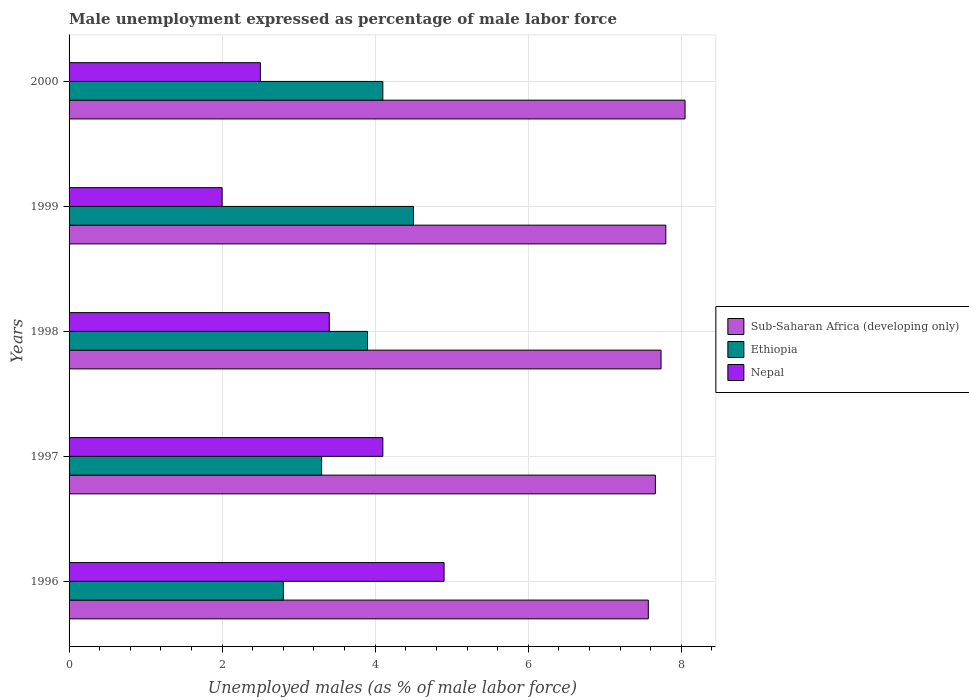Are the number of bars per tick equal to the number of legend labels?
Ensure brevity in your answer.  Yes. Are the number of bars on each tick of the Y-axis equal?
Ensure brevity in your answer.  Yes. How many bars are there on the 2nd tick from the bottom?
Your response must be concise. 3. In how many cases, is the number of bars for a given year not equal to the number of legend labels?
Your response must be concise. 0. What is the unemployment in males in in Nepal in 1997?
Provide a short and direct response. 4.1. Across all years, what is the maximum unemployment in males in in Sub-Saharan Africa (developing only)?
Provide a short and direct response. 8.05. Across all years, what is the minimum unemployment in males in in Ethiopia?
Offer a very short reply. 2.8. In which year was the unemployment in males in in Nepal maximum?
Provide a succinct answer. 1996. In which year was the unemployment in males in in Ethiopia minimum?
Keep it short and to the point. 1996. What is the total unemployment in males in in Sub-Saharan Africa (developing only) in the graph?
Keep it short and to the point. 38.81. What is the difference between the unemployment in males in in Ethiopia in 1996 and that in 2000?
Offer a very short reply. -1.3. What is the difference between the unemployment in males in in Nepal in 1996 and the unemployment in males in in Ethiopia in 2000?
Offer a very short reply. 0.8. What is the average unemployment in males in in Nepal per year?
Provide a short and direct response. 3.38. In the year 2000, what is the difference between the unemployment in males in in Nepal and unemployment in males in in Sub-Saharan Africa (developing only)?
Ensure brevity in your answer.  -5.55. What is the ratio of the unemployment in males in in Ethiopia in 1996 to that in 1999?
Provide a succinct answer. 0.62. What is the difference between the highest and the second highest unemployment in males in in Nepal?
Keep it short and to the point. 0.8. What is the difference between the highest and the lowest unemployment in males in in Sub-Saharan Africa (developing only)?
Your answer should be very brief. 0.48. What does the 2nd bar from the top in 1999 represents?
Your answer should be very brief. Ethiopia. What does the 2nd bar from the bottom in 2000 represents?
Keep it short and to the point. Ethiopia. Is it the case that in every year, the sum of the unemployment in males in in Ethiopia and unemployment in males in in Sub-Saharan Africa (developing only) is greater than the unemployment in males in in Nepal?
Provide a succinct answer. Yes. What is the difference between two consecutive major ticks on the X-axis?
Offer a very short reply. 2. Are the values on the major ticks of X-axis written in scientific E-notation?
Your answer should be compact. No. How many legend labels are there?
Your answer should be compact. 3. How are the legend labels stacked?
Ensure brevity in your answer.  Vertical. What is the title of the graph?
Your answer should be very brief. Male unemployment expressed as percentage of male labor force. What is the label or title of the X-axis?
Offer a very short reply. Unemployed males (as % of male labor force). What is the label or title of the Y-axis?
Your answer should be very brief. Years. What is the Unemployed males (as % of male labor force) in Sub-Saharan Africa (developing only) in 1996?
Your response must be concise. 7.57. What is the Unemployed males (as % of male labor force) of Ethiopia in 1996?
Your answer should be compact. 2.8. What is the Unemployed males (as % of male labor force) of Nepal in 1996?
Provide a short and direct response. 4.9. What is the Unemployed males (as % of male labor force) of Sub-Saharan Africa (developing only) in 1997?
Ensure brevity in your answer.  7.66. What is the Unemployed males (as % of male labor force) in Ethiopia in 1997?
Keep it short and to the point. 3.3. What is the Unemployed males (as % of male labor force) in Nepal in 1997?
Your answer should be compact. 4.1. What is the Unemployed males (as % of male labor force) of Sub-Saharan Africa (developing only) in 1998?
Make the answer very short. 7.74. What is the Unemployed males (as % of male labor force) in Ethiopia in 1998?
Provide a succinct answer. 3.9. What is the Unemployed males (as % of male labor force) of Nepal in 1998?
Your answer should be compact. 3.4. What is the Unemployed males (as % of male labor force) of Sub-Saharan Africa (developing only) in 1999?
Your answer should be compact. 7.8. What is the Unemployed males (as % of male labor force) of Ethiopia in 1999?
Your response must be concise. 4.5. What is the Unemployed males (as % of male labor force) in Sub-Saharan Africa (developing only) in 2000?
Offer a very short reply. 8.05. What is the Unemployed males (as % of male labor force) of Ethiopia in 2000?
Ensure brevity in your answer.  4.1. Across all years, what is the maximum Unemployed males (as % of male labor force) of Sub-Saharan Africa (developing only)?
Offer a very short reply. 8.05. Across all years, what is the maximum Unemployed males (as % of male labor force) of Ethiopia?
Offer a very short reply. 4.5. Across all years, what is the maximum Unemployed males (as % of male labor force) in Nepal?
Offer a terse response. 4.9. Across all years, what is the minimum Unemployed males (as % of male labor force) in Sub-Saharan Africa (developing only)?
Provide a short and direct response. 7.57. Across all years, what is the minimum Unemployed males (as % of male labor force) in Ethiopia?
Provide a succinct answer. 2.8. What is the total Unemployed males (as % of male labor force) of Sub-Saharan Africa (developing only) in the graph?
Offer a very short reply. 38.81. What is the total Unemployed males (as % of male labor force) in Nepal in the graph?
Provide a short and direct response. 16.9. What is the difference between the Unemployed males (as % of male labor force) in Sub-Saharan Africa (developing only) in 1996 and that in 1997?
Your response must be concise. -0.09. What is the difference between the Unemployed males (as % of male labor force) of Nepal in 1996 and that in 1997?
Keep it short and to the point. 0.8. What is the difference between the Unemployed males (as % of male labor force) of Sub-Saharan Africa (developing only) in 1996 and that in 1998?
Provide a succinct answer. -0.17. What is the difference between the Unemployed males (as % of male labor force) in Nepal in 1996 and that in 1998?
Make the answer very short. 1.5. What is the difference between the Unemployed males (as % of male labor force) of Sub-Saharan Africa (developing only) in 1996 and that in 1999?
Offer a very short reply. -0.23. What is the difference between the Unemployed males (as % of male labor force) in Ethiopia in 1996 and that in 1999?
Ensure brevity in your answer.  -1.7. What is the difference between the Unemployed males (as % of male labor force) of Sub-Saharan Africa (developing only) in 1996 and that in 2000?
Ensure brevity in your answer.  -0.48. What is the difference between the Unemployed males (as % of male labor force) in Ethiopia in 1996 and that in 2000?
Your answer should be very brief. -1.3. What is the difference between the Unemployed males (as % of male labor force) in Nepal in 1996 and that in 2000?
Offer a terse response. 2.4. What is the difference between the Unemployed males (as % of male labor force) of Sub-Saharan Africa (developing only) in 1997 and that in 1998?
Make the answer very short. -0.07. What is the difference between the Unemployed males (as % of male labor force) in Ethiopia in 1997 and that in 1998?
Provide a short and direct response. -0.6. What is the difference between the Unemployed males (as % of male labor force) in Sub-Saharan Africa (developing only) in 1997 and that in 1999?
Your response must be concise. -0.14. What is the difference between the Unemployed males (as % of male labor force) in Ethiopia in 1997 and that in 1999?
Provide a short and direct response. -1.2. What is the difference between the Unemployed males (as % of male labor force) of Nepal in 1997 and that in 1999?
Your answer should be compact. 2.1. What is the difference between the Unemployed males (as % of male labor force) in Sub-Saharan Africa (developing only) in 1997 and that in 2000?
Make the answer very short. -0.39. What is the difference between the Unemployed males (as % of male labor force) in Sub-Saharan Africa (developing only) in 1998 and that in 1999?
Offer a terse response. -0.06. What is the difference between the Unemployed males (as % of male labor force) of Ethiopia in 1998 and that in 1999?
Ensure brevity in your answer.  -0.6. What is the difference between the Unemployed males (as % of male labor force) of Sub-Saharan Africa (developing only) in 1998 and that in 2000?
Your response must be concise. -0.31. What is the difference between the Unemployed males (as % of male labor force) of Ethiopia in 1998 and that in 2000?
Make the answer very short. -0.2. What is the difference between the Unemployed males (as % of male labor force) in Sub-Saharan Africa (developing only) in 1999 and that in 2000?
Keep it short and to the point. -0.25. What is the difference between the Unemployed males (as % of male labor force) of Sub-Saharan Africa (developing only) in 1996 and the Unemployed males (as % of male labor force) of Ethiopia in 1997?
Give a very brief answer. 4.27. What is the difference between the Unemployed males (as % of male labor force) of Sub-Saharan Africa (developing only) in 1996 and the Unemployed males (as % of male labor force) of Nepal in 1997?
Give a very brief answer. 3.47. What is the difference between the Unemployed males (as % of male labor force) of Ethiopia in 1996 and the Unemployed males (as % of male labor force) of Nepal in 1997?
Provide a succinct answer. -1.3. What is the difference between the Unemployed males (as % of male labor force) of Sub-Saharan Africa (developing only) in 1996 and the Unemployed males (as % of male labor force) of Ethiopia in 1998?
Provide a succinct answer. 3.67. What is the difference between the Unemployed males (as % of male labor force) of Sub-Saharan Africa (developing only) in 1996 and the Unemployed males (as % of male labor force) of Nepal in 1998?
Provide a succinct answer. 4.17. What is the difference between the Unemployed males (as % of male labor force) in Sub-Saharan Africa (developing only) in 1996 and the Unemployed males (as % of male labor force) in Ethiopia in 1999?
Keep it short and to the point. 3.07. What is the difference between the Unemployed males (as % of male labor force) in Sub-Saharan Africa (developing only) in 1996 and the Unemployed males (as % of male labor force) in Nepal in 1999?
Your answer should be very brief. 5.57. What is the difference between the Unemployed males (as % of male labor force) of Ethiopia in 1996 and the Unemployed males (as % of male labor force) of Nepal in 1999?
Keep it short and to the point. 0.8. What is the difference between the Unemployed males (as % of male labor force) in Sub-Saharan Africa (developing only) in 1996 and the Unemployed males (as % of male labor force) in Ethiopia in 2000?
Provide a short and direct response. 3.47. What is the difference between the Unemployed males (as % of male labor force) in Sub-Saharan Africa (developing only) in 1996 and the Unemployed males (as % of male labor force) in Nepal in 2000?
Make the answer very short. 5.07. What is the difference between the Unemployed males (as % of male labor force) of Sub-Saharan Africa (developing only) in 1997 and the Unemployed males (as % of male labor force) of Ethiopia in 1998?
Provide a short and direct response. 3.76. What is the difference between the Unemployed males (as % of male labor force) of Sub-Saharan Africa (developing only) in 1997 and the Unemployed males (as % of male labor force) of Nepal in 1998?
Provide a succinct answer. 4.26. What is the difference between the Unemployed males (as % of male labor force) in Ethiopia in 1997 and the Unemployed males (as % of male labor force) in Nepal in 1998?
Ensure brevity in your answer.  -0.1. What is the difference between the Unemployed males (as % of male labor force) in Sub-Saharan Africa (developing only) in 1997 and the Unemployed males (as % of male labor force) in Ethiopia in 1999?
Provide a short and direct response. 3.16. What is the difference between the Unemployed males (as % of male labor force) in Sub-Saharan Africa (developing only) in 1997 and the Unemployed males (as % of male labor force) in Nepal in 1999?
Ensure brevity in your answer.  5.66. What is the difference between the Unemployed males (as % of male labor force) in Ethiopia in 1997 and the Unemployed males (as % of male labor force) in Nepal in 1999?
Your response must be concise. 1.3. What is the difference between the Unemployed males (as % of male labor force) of Sub-Saharan Africa (developing only) in 1997 and the Unemployed males (as % of male labor force) of Ethiopia in 2000?
Offer a terse response. 3.56. What is the difference between the Unemployed males (as % of male labor force) in Sub-Saharan Africa (developing only) in 1997 and the Unemployed males (as % of male labor force) in Nepal in 2000?
Offer a very short reply. 5.16. What is the difference between the Unemployed males (as % of male labor force) of Sub-Saharan Africa (developing only) in 1998 and the Unemployed males (as % of male labor force) of Ethiopia in 1999?
Your answer should be very brief. 3.24. What is the difference between the Unemployed males (as % of male labor force) in Sub-Saharan Africa (developing only) in 1998 and the Unemployed males (as % of male labor force) in Nepal in 1999?
Make the answer very short. 5.74. What is the difference between the Unemployed males (as % of male labor force) of Ethiopia in 1998 and the Unemployed males (as % of male labor force) of Nepal in 1999?
Your answer should be very brief. 1.9. What is the difference between the Unemployed males (as % of male labor force) in Sub-Saharan Africa (developing only) in 1998 and the Unemployed males (as % of male labor force) in Ethiopia in 2000?
Keep it short and to the point. 3.64. What is the difference between the Unemployed males (as % of male labor force) of Sub-Saharan Africa (developing only) in 1998 and the Unemployed males (as % of male labor force) of Nepal in 2000?
Ensure brevity in your answer.  5.24. What is the difference between the Unemployed males (as % of male labor force) of Sub-Saharan Africa (developing only) in 1999 and the Unemployed males (as % of male labor force) of Ethiopia in 2000?
Ensure brevity in your answer.  3.7. What is the difference between the Unemployed males (as % of male labor force) in Sub-Saharan Africa (developing only) in 1999 and the Unemployed males (as % of male labor force) in Nepal in 2000?
Provide a short and direct response. 5.3. What is the average Unemployed males (as % of male labor force) in Sub-Saharan Africa (developing only) per year?
Offer a very short reply. 7.76. What is the average Unemployed males (as % of male labor force) in Ethiopia per year?
Your answer should be very brief. 3.72. What is the average Unemployed males (as % of male labor force) in Nepal per year?
Offer a very short reply. 3.38. In the year 1996, what is the difference between the Unemployed males (as % of male labor force) in Sub-Saharan Africa (developing only) and Unemployed males (as % of male labor force) in Ethiopia?
Give a very brief answer. 4.77. In the year 1996, what is the difference between the Unemployed males (as % of male labor force) in Sub-Saharan Africa (developing only) and Unemployed males (as % of male labor force) in Nepal?
Offer a terse response. 2.67. In the year 1996, what is the difference between the Unemployed males (as % of male labor force) of Ethiopia and Unemployed males (as % of male labor force) of Nepal?
Provide a succinct answer. -2.1. In the year 1997, what is the difference between the Unemployed males (as % of male labor force) of Sub-Saharan Africa (developing only) and Unemployed males (as % of male labor force) of Ethiopia?
Provide a succinct answer. 4.36. In the year 1997, what is the difference between the Unemployed males (as % of male labor force) in Sub-Saharan Africa (developing only) and Unemployed males (as % of male labor force) in Nepal?
Make the answer very short. 3.56. In the year 1998, what is the difference between the Unemployed males (as % of male labor force) in Sub-Saharan Africa (developing only) and Unemployed males (as % of male labor force) in Ethiopia?
Ensure brevity in your answer.  3.84. In the year 1998, what is the difference between the Unemployed males (as % of male labor force) of Sub-Saharan Africa (developing only) and Unemployed males (as % of male labor force) of Nepal?
Provide a short and direct response. 4.34. In the year 1999, what is the difference between the Unemployed males (as % of male labor force) in Sub-Saharan Africa (developing only) and Unemployed males (as % of male labor force) in Ethiopia?
Give a very brief answer. 3.3. In the year 1999, what is the difference between the Unemployed males (as % of male labor force) in Sub-Saharan Africa (developing only) and Unemployed males (as % of male labor force) in Nepal?
Provide a succinct answer. 5.8. In the year 2000, what is the difference between the Unemployed males (as % of male labor force) of Sub-Saharan Africa (developing only) and Unemployed males (as % of male labor force) of Ethiopia?
Give a very brief answer. 3.95. In the year 2000, what is the difference between the Unemployed males (as % of male labor force) in Sub-Saharan Africa (developing only) and Unemployed males (as % of male labor force) in Nepal?
Offer a very short reply. 5.55. What is the ratio of the Unemployed males (as % of male labor force) in Ethiopia in 1996 to that in 1997?
Offer a very short reply. 0.85. What is the ratio of the Unemployed males (as % of male labor force) in Nepal in 1996 to that in 1997?
Make the answer very short. 1.2. What is the ratio of the Unemployed males (as % of male labor force) of Sub-Saharan Africa (developing only) in 1996 to that in 1998?
Keep it short and to the point. 0.98. What is the ratio of the Unemployed males (as % of male labor force) in Ethiopia in 1996 to that in 1998?
Provide a succinct answer. 0.72. What is the ratio of the Unemployed males (as % of male labor force) in Nepal in 1996 to that in 1998?
Give a very brief answer. 1.44. What is the ratio of the Unemployed males (as % of male labor force) of Sub-Saharan Africa (developing only) in 1996 to that in 1999?
Provide a short and direct response. 0.97. What is the ratio of the Unemployed males (as % of male labor force) of Ethiopia in 1996 to that in 1999?
Your answer should be very brief. 0.62. What is the ratio of the Unemployed males (as % of male labor force) in Nepal in 1996 to that in 1999?
Your response must be concise. 2.45. What is the ratio of the Unemployed males (as % of male labor force) in Sub-Saharan Africa (developing only) in 1996 to that in 2000?
Provide a short and direct response. 0.94. What is the ratio of the Unemployed males (as % of male labor force) in Ethiopia in 1996 to that in 2000?
Offer a terse response. 0.68. What is the ratio of the Unemployed males (as % of male labor force) in Nepal in 1996 to that in 2000?
Your answer should be very brief. 1.96. What is the ratio of the Unemployed males (as % of male labor force) in Ethiopia in 1997 to that in 1998?
Keep it short and to the point. 0.85. What is the ratio of the Unemployed males (as % of male labor force) in Nepal in 1997 to that in 1998?
Offer a terse response. 1.21. What is the ratio of the Unemployed males (as % of male labor force) in Sub-Saharan Africa (developing only) in 1997 to that in 1999?
Provide a succinct answer. 0.98. What is the ratio of the Unemployed males (as % of male labor force) in Ethiopia in 1997 to that in 1999?
Provide a succinct answer. 0.73. What is the ratio of the Unemployed males (as % of male labor force) of Nepal in 1997 to that in 1999?
Your answer should be very brief. 2.05. What is the ratio of the Unemployed males (as % of male labor force) in Sub-Saharan Africa (developing only) in 1997 to that in 2000?
Your response must be concise. 0.95. What is the ratio of the Unemployed males (as % of male labor force) in Ethiopia in 1997 to that in 2000?
Your response must be concise. 0.8. What is the ratio of the Unemployed males (as % of male labor force) in Nepal in 1997 to that in 2000?
Give a very brief answer. 1.64. What is the ratio of the Unemployed males (as % of male labor force) in Sub-Saharan Africa (developing only) in 1998 to that in 1999?
Provide a succinct answer. 0.99. What is the ratio of the Unemployed males (as % of male labor force) in Ethiopia in 1998 to that in 1999?
Your response must be concise. 0.87. What is the ratio of the Unemployed males (as % of male labor force) of Sub-Saharan Africa (developing only) in 1998 to that in 2000?
Provide a succinct answer. 0.96. What is the ratio of the Unemployed males (as % of male labor force) in Ethiopia in 1998 to that in 2000?
Give a very brief answer. 0.95. What is the ratio of the Unemployed males (as % of male labor force) of Nepal in 1998 to that in 2000?
Keep it short and to the point. 1.36. What is the ratio of the Unemployed males (as % of male labor force) of Sub-Saharan Africa (developing only) in 1999 to that in 2000?
Keep it short and to the point. 0.97. What is the ratio of the Unemployed males (as % of male labor force) in Ethiopia in 1999 to that in 2000?
Your response must be concise. 1.1. What is the difference between the highest and the second highest Unemployed males (as % of male labor force) of Sub-Saharan Africa (developing only)?
Provide a short and direct response. 0.25. What is the difference between the highest and the second highest Unemployed males (as % of male labor force) of Ethiopia?
Keep it short and to the point. 0.4. What is the difference between the highest and the second highest Unemployed males (as % of male labor force) of Nepal?
Ensure brevity in your answer.  0.8. What is the difference between the highest and the lowest Unemployed males (as % of male labor force) in Sub-Saharan Africa (developing only)?
Your response must be concise. 0.48. What is the difference between the highest and the lowest Unemployed males (as % of male labor force) in Ethiopia?
Keep it short and to the point. 1.7. 